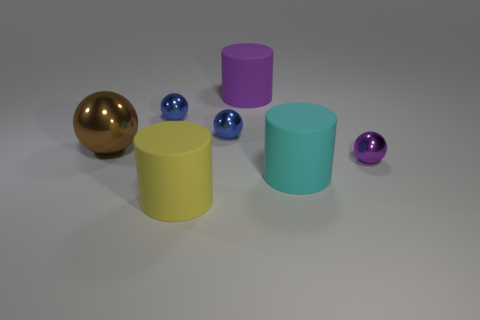There is a large purple thing behind the yellow object; what is it made of?
Your answer should be very brief. Rubber. What number of rubber objects are blue things or cyan cylinders?
Provide a short and direct response. 1. Is there a cyan cylinder of the same size as the purple matte cylinder?
Make the answer very short. Yes. Is the number of metallic balls that are in front of the purple matte thing greater than the number of tiny blue rubber blocks?
Provide a succinct answer. Yes. How many tiny things are purple matte cylinders or blue metal things?
Provide a short and direct response. 2. What number of purple objects are the same shape as the cyan object?
Ensure brevity in your answer.  1. What is the material of the blue thing to the right of the small metal thing that is to the left of the yellow rubber object?
Ensure brevity in your answer.  Metal. What size is the thing that is in front of the cyan cylinder?
Offer a very short reply. Large. How many blue objects are large metal spheres or tiny metallic things?
Provide a succinct answer. 2. There is a big brown thing that is the same shape as the purple shiny thing; what material is it?
Your answer should be compact. Metal. 